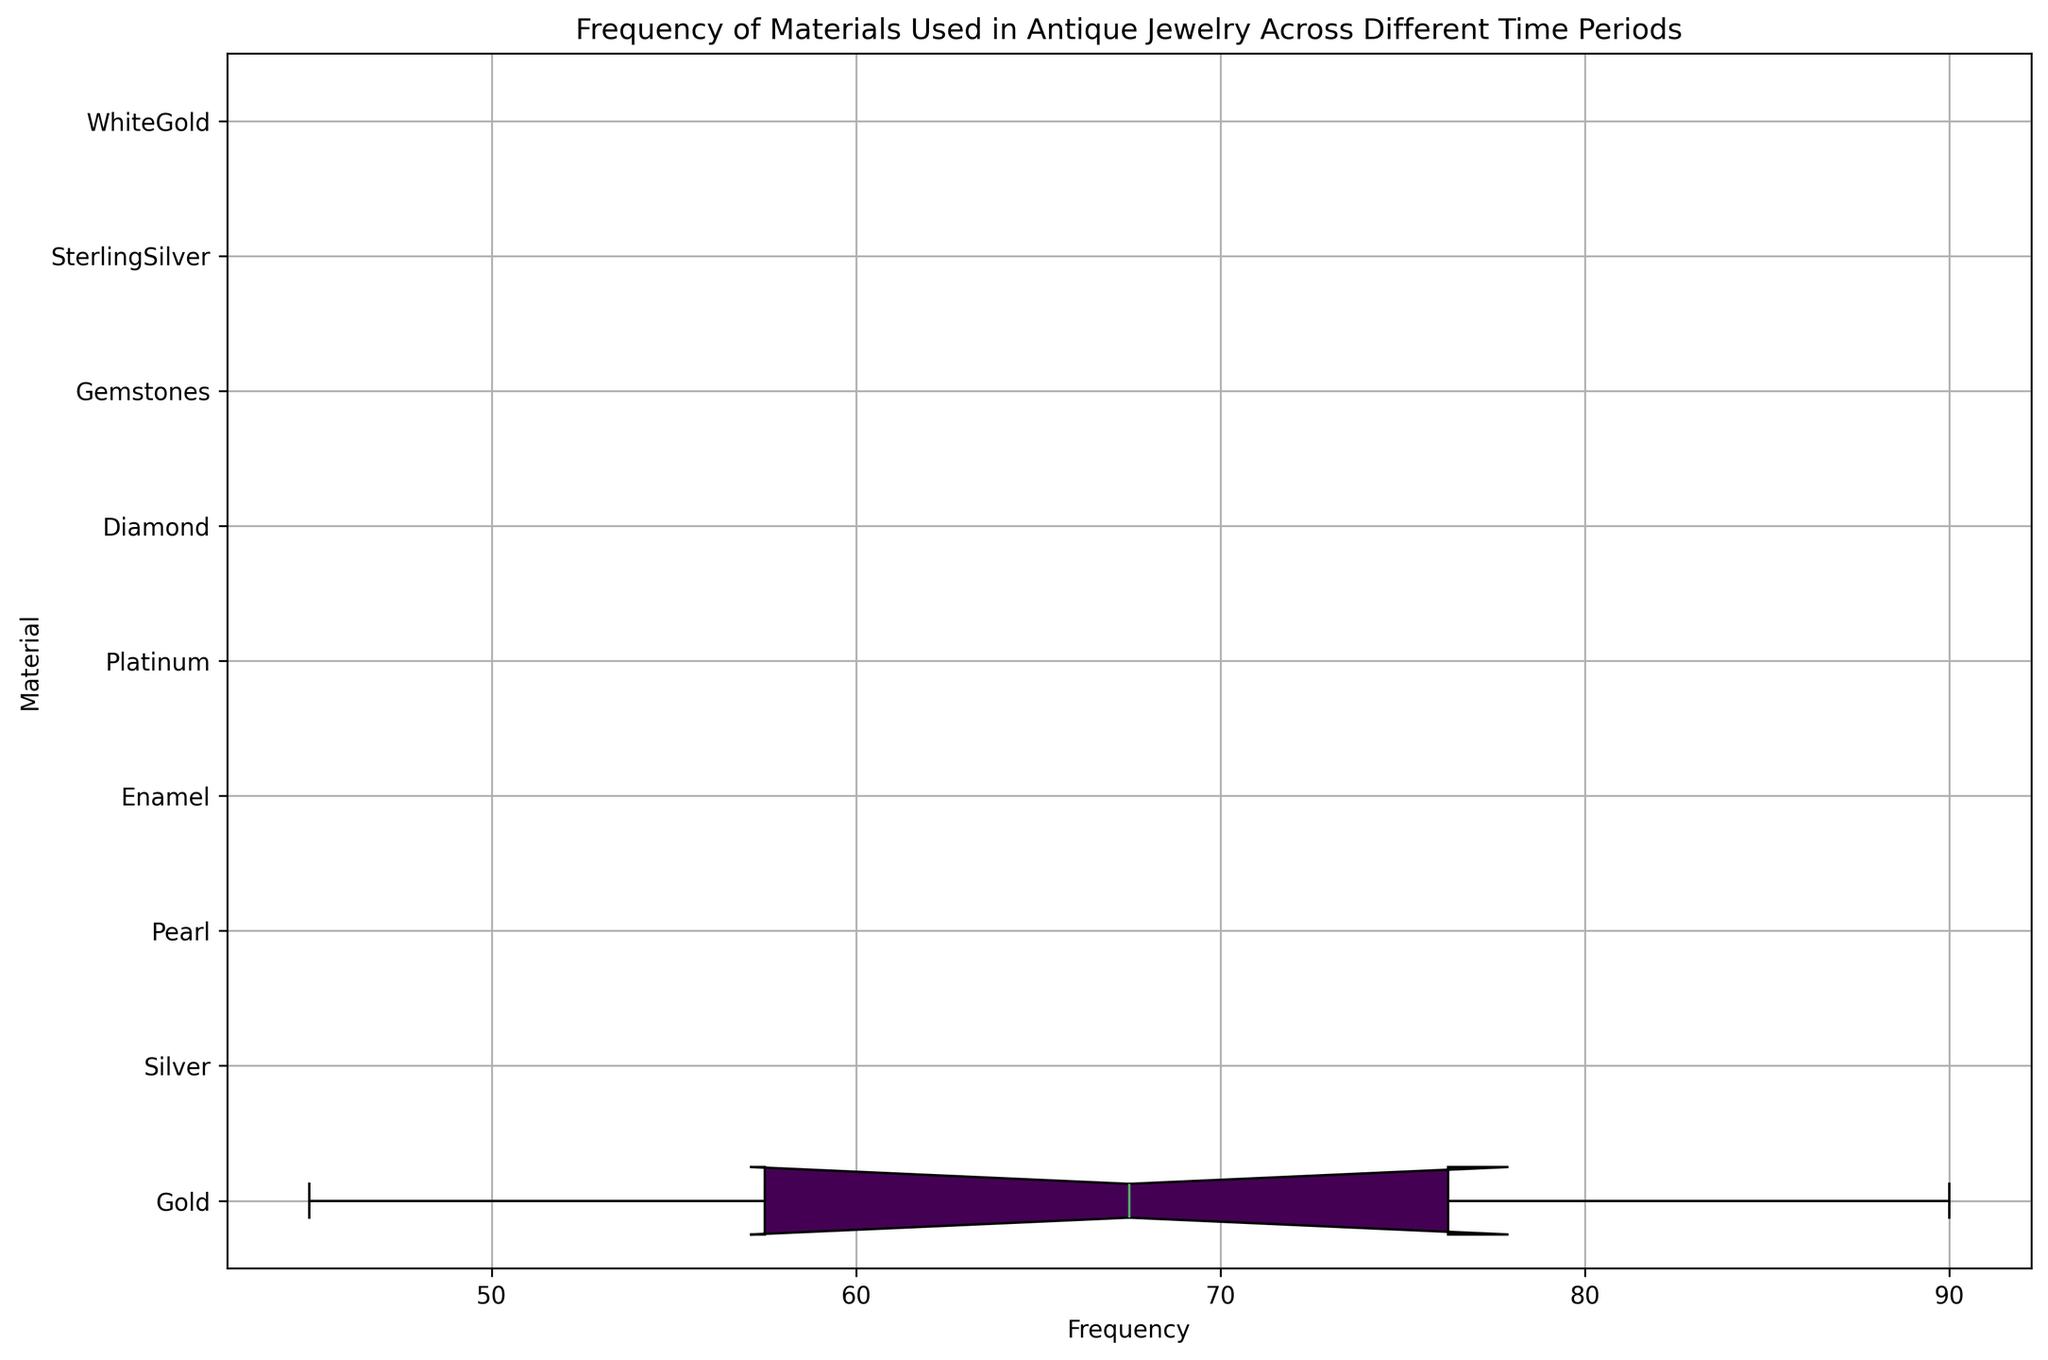Which material has the highest median frequency across all time periods? By inspecting the box plot, the material with the highest median frequency is identified by noting which box's horizontal line in the middle is farthest to the right.
Answer: Platinum Which material has the widest range in frequency usage across all time periods? To find the material with the widest range, compare the lengths of the boxes and whiskers for each material. The material with the longest total length (box plus whiskers) has the widest range.
Answer: Gold What is the average frequency of Enamel across all time periods it is used? Enamel is used in the Art Nouveau and Retro periods with frequencies of 25 and 40 respectively. The average frequency is calculated by summing these values and dividing by the number of periods Enamel is used in: (25 + 40) / 2 = 32.5
Answer: 32.5 Which material has the least variability in frequency usage across all time periods? The material with the least variability has the shortest total length of its box and whiskers. Inspect the plot to find which material fits this description.
Answer: Diamond How does the interquartile range (IQR) of Gold compare to the IQR of Platinum? Measure the length of the box for Gold and compare it to the length of the box for Platinum. The IQR is the length of the box, representing the middle 50% of the data.
Answer: Gold has a larger IQR than Platinum Is there any material that has the same interquartile range (IQR) as another? Compare the lengths of the boxes for all materials. Identify any two materials with boxes of exactly the same length.
Answer: No, all materials have different IQRs Which material used in the Edwardian period has the highest frequency? Look at the Edwardian period's frequencies for the materials: Platinum (80), Gold (45), and Diamond (70). The material with the highest value is Platinum.
Answer: Platinum What is the total frequency of SterlingSilver across all time periods it is used? SterlingSilver is used in the Retro and Modern periods with frequencies of 30 and 50 respectively. The total frequency is calculated by summing these values: 30 + 50 = 80.
Answer: 80 How does the usage frequency of Pearl compare between the Georgian and Victorian periods? Pearl has frequencies of 20 in the Georgian period and 60 in the Victorian period. Comparing these values shows that Pearl is used more often in the Victorian period.
Answer: Used more in Victorian Which material in the Art Deco period has the second highest frequency of usage? Look at the frequencies of materials for the Art Deco period: Platinum (85), Gold (60), Gemstones (50). The material with the second highest frequency is Gold.
Answer: Gold 